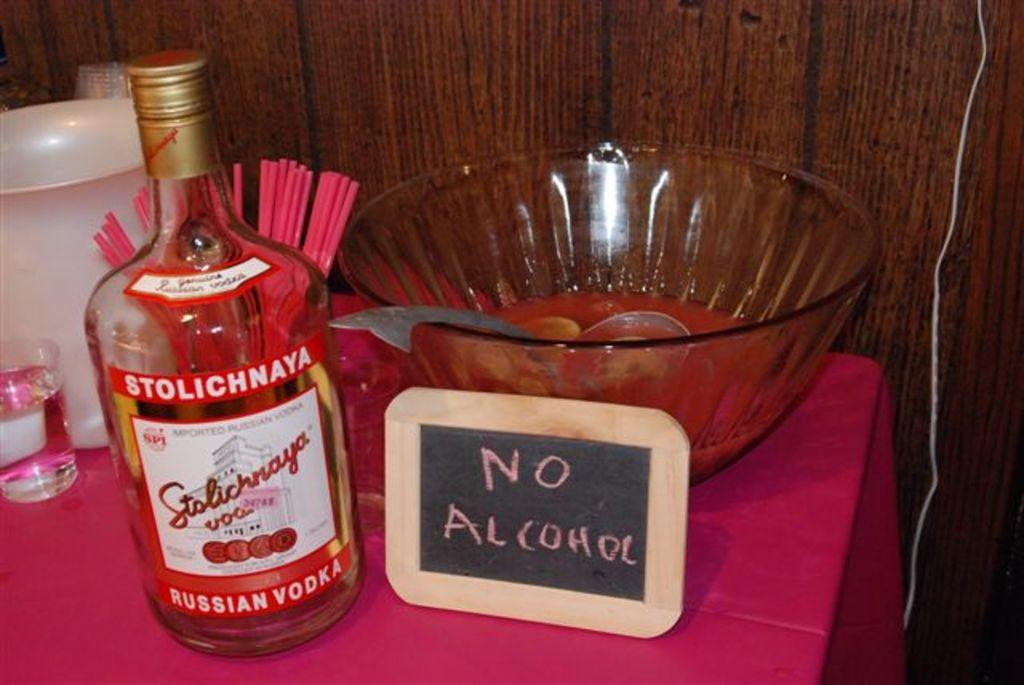In one or two sentences, can you explain what this image depicts? In this image we can see a bottle with label on it, a board, bowl with spoon in it, glass, jug and straws placed on the table. In the background we can see a wooden wall. 